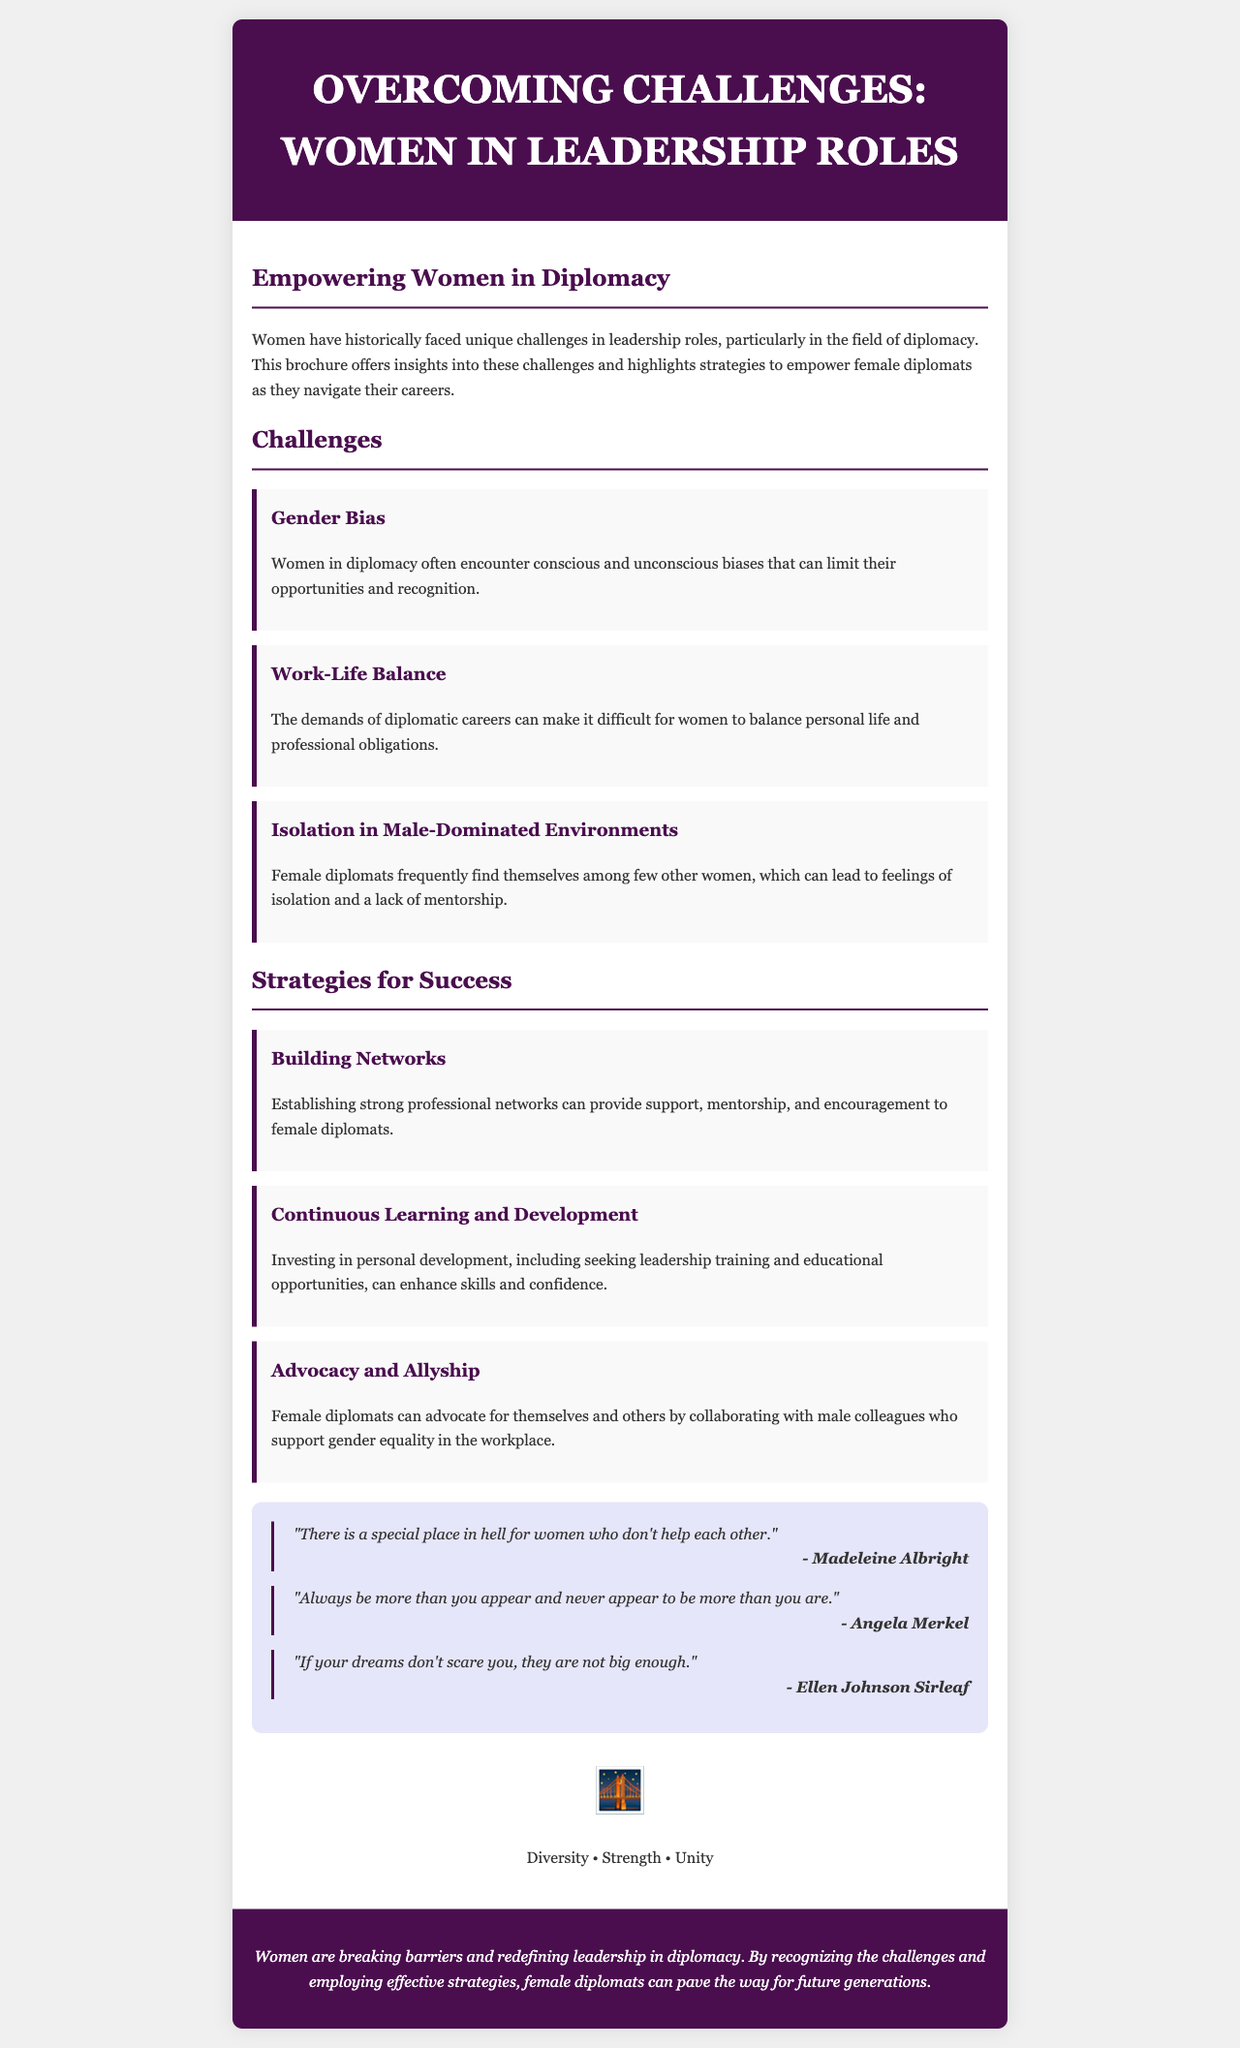What is the title of the brochure? The title is prominently displayed in the header section of the brochure.
Answer: Overcoming Challenges: Women in Leadership Roles Who is the author of the quote about women helping each other? The quote is attributed to a prominent female diplomat, shown in the quotes section of the brochure.
Answer: Madeleine Albright Which challenge involves feelings of isolation? This challenge is listed under the specific challenges section and highlights the experiences of female diplomats.
Answer: Isolation in Male-Dominated Environments What strategy focuses on personal development? This strategy aims to enhance skills and confidence through continuous education, mentioned in the strategies for success section.
Answer: Continuous Learning and Development How many challenges are mentioned in the document? The challenges are clearly outlined in the challenges section, and counting them gives the total number.
Answer: Three What does the visual symbol before the motto represent? The visual symbol is included to evoke a specific sense related to the themes of the document.
Answer: Diversity What is the color of the header background? The brochure's design specifies a color used in the header, which contributes to its overall aesthetic.
Answer: Dark purple Which notable female leader mentioned a quote about dreams? The quote related to dreams is attributed to a significant figure in leadership, as noted in the quotes section.
Answer: Ellen Johnson Sirleaf 